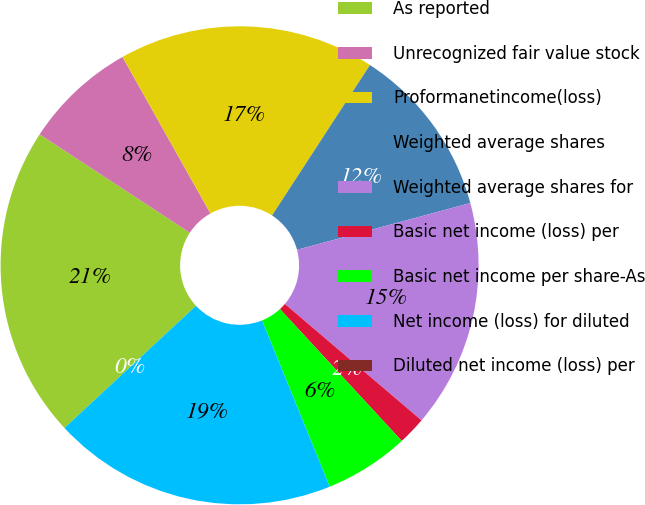<chart> <loc_0><loc_0><loc_500><loc_500><pie_chart><fcel>As reported<fcel>Unrecognized fair value stock<fcel>Proformanetincome(loss)<fcel>Weighted average shares<fcel>Weighted average shares for<fcel>Basic net income (loss) per<fcel>Basic net income per share-As<fcel>Net income (loss) for diluted<fcel>Diluted net income (loss) per<nl><fcel>21.14%<fcel>7.62%<fcel>17.33%<fcel>11.62%<fcel>15.43%<fcel>1.9%<fcel>5.71%<fcel>19.24%<fcel>0.0%<nl></chart> 